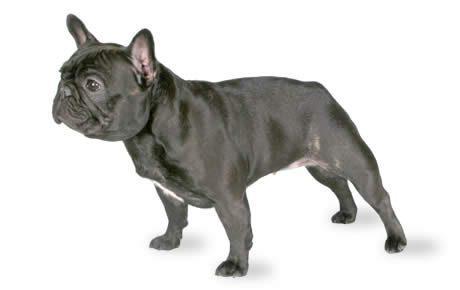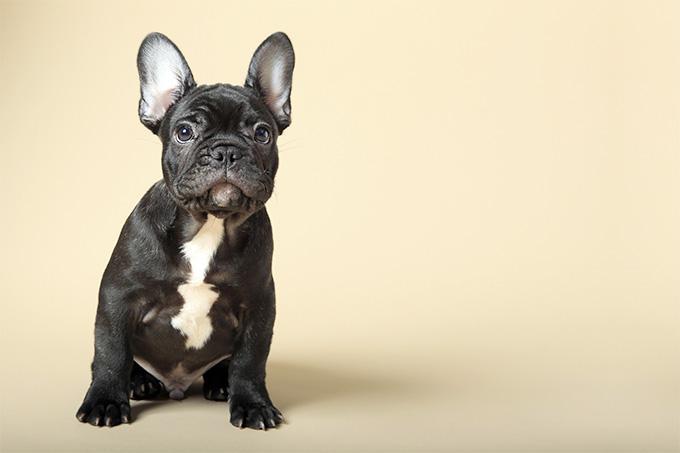The first image is the image on the left, the second image is the image on the right. Considering the images on both sides, is "The dog in the image on the right is mostly black." valid? Answer yes or no. Yes. 